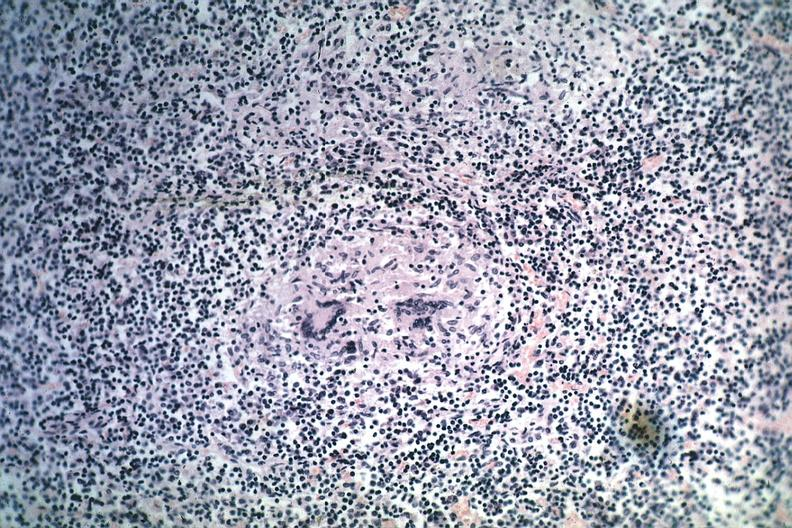s tuberculosis present?
Answer the question using a single word or phrase. Yes 